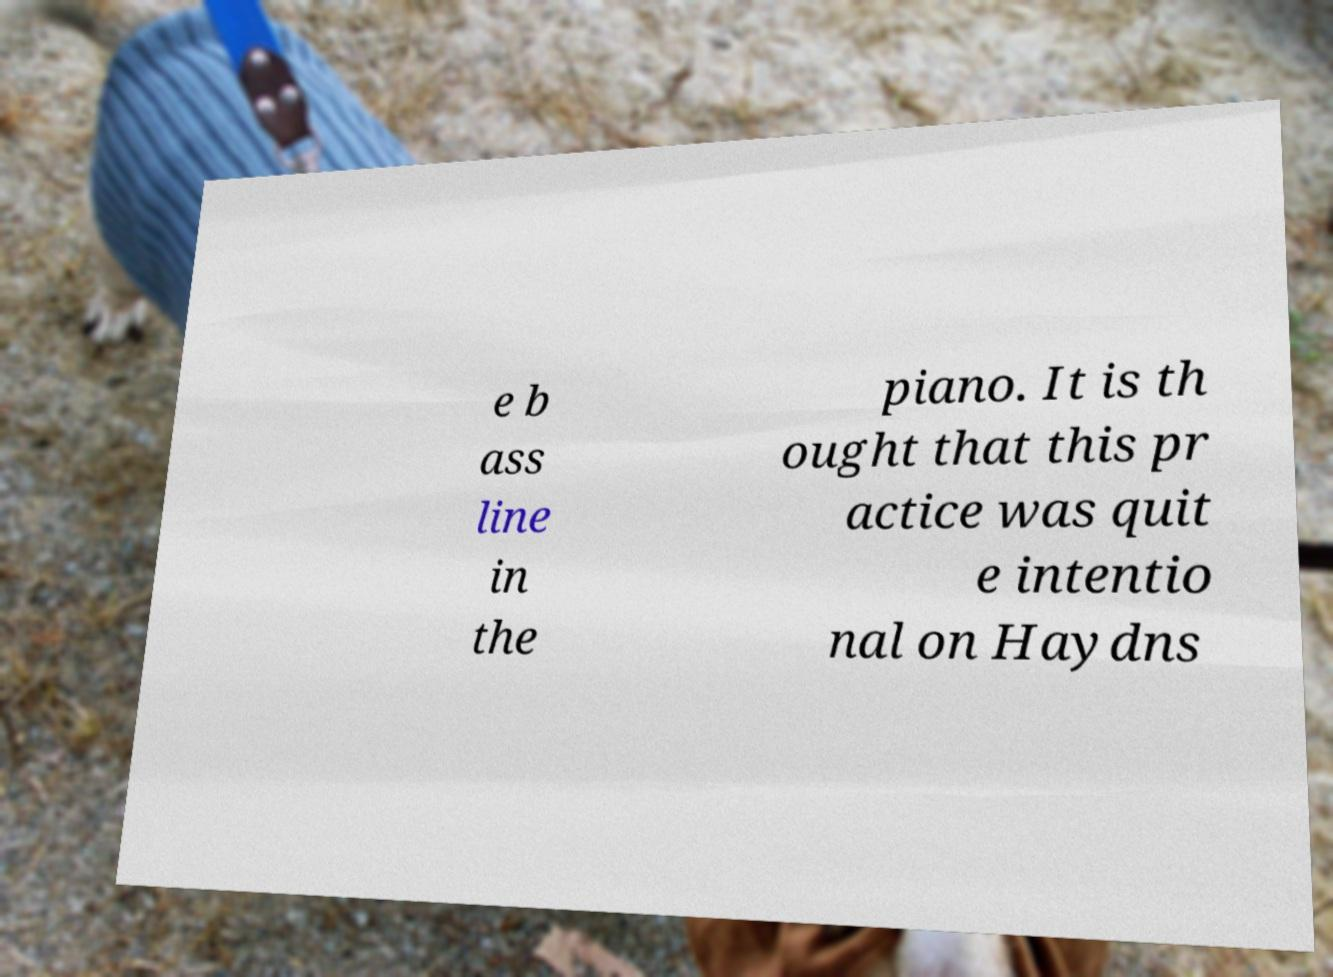Could you extract and type out the text from this image? e b ass line in the piano. It is th ought that this pr actice was quit e intentio nal on Haydns 